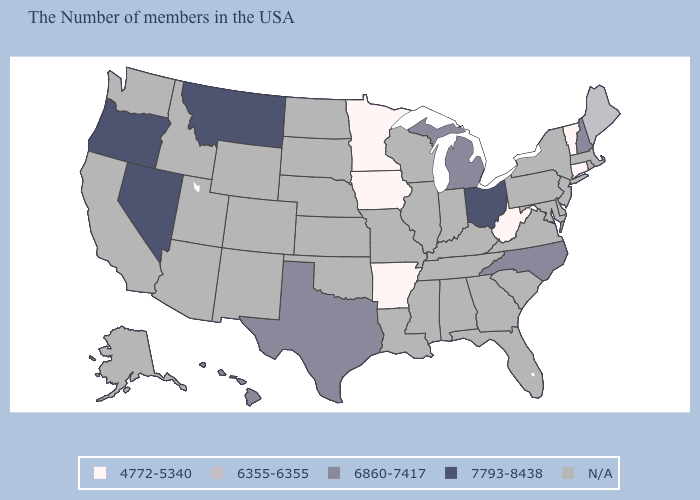Does the map have missing data?
Short answer required. Yes. Does the first symbol in the legend represent the smallest category?
Concise answer only. Yes. What is the lowest value in the USA?
Short answer required. 4772-5340. What is the value of New Jersey?
Answer briefly. N/A. Name the states that have a value in the range 6355-6355?
Concise answer only. Maine. Does Michigan have the lowest value in the MidWest?
Write a very short answer. No. Among the states that border Iowa , which have the lowest value?
Concise answer only. Minnesota. Does West Virginia have the lowest value in the USA?
Short answer required. Yes. What is the value of Michigan?
Quick response, please. 6860-7417. What is the value of Arkansas?
Be succinct. 4772-5340. What is the value of Indiana?
Short answer required. N/A. What is the value of Florida?
Write a very short answer. N/A. Which states hav the highest value in the West?
Write a very short answer. Montana, Nevada, Oregon. Name the states that have a value in the range 7793-8438?
Give a very brief answer. Ohio, Montana, Nevada, Oregon. Does Maine have the lowest value in the USA?
Keep it brief. No. 